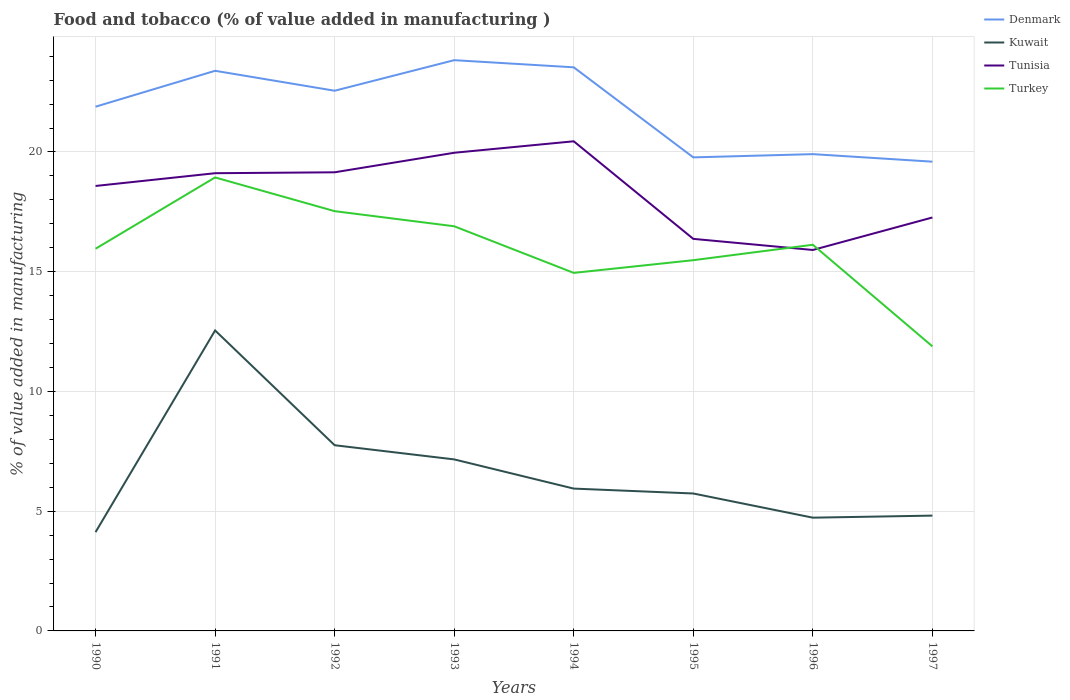How many different coloured lines are there?
Provide a succinct answer. 4. Does the line corresponding to Tunisia intersect with the line corresponding to Denmark?
Make the answer very short. No. Is the number of lines equal to the number of legend labels?
Your response must be concise. Yes. Across all years, what is the maximum value added in manufacturing food and tobacco in Tunisia?
Make the answer very short. 15.91. What is the total value added in manufacturing food and tobacco in Turkey in the graph?
Keep it short and to the point. -2.98. What is the difference between the highest and the second highest value added in manufacturing food and tobacco in Tunisia?
Provide a succinct answer. 4.54. What is the difference between the highest and the lowest value added in manufacturing food and tobacco in Tunisia?
Provide a succinct answer. 5. Is the value added in manufacturing food and tobacco in Tunisia strictly greater than the value added in manufacturing food and tobacco in Turkey over the years?
Ensure brevity in your answer.  No. How many lines are there?
Offer a very short reply. 4. Are the values on the major ticks of Y-axis written in scientific E-notation?
Offer a terse response. No. Does the graph contain any zero values?
Your response must be concise. No. Does the graph contain grids?
Your response must be concise. Yes. Where does the legend appear in the graph?
Give a very brief answer. Top right. What is the title of the graph?
Provide a succinct answer. Food and tobacco (% of value added in manufacturing ). Does "Middle East & North Africa (all income levels)" appear as one of the legend labels in the graph?
Provide a short and direct response. No. What is the label or title of the X-axis?
Ensure brevity in your answer.  Years. What is the label or title of the Y-axis?
Offer a very short reply. % of value added in manufacturing. What is the % of value added in manufacturing of Denmark in 1990?
Offer a terse response. 21.89. What is the % of value added in manufacturing in Kuwait in 1990?
Offer a terse response. 4.13. What is the % of value added in manufacturing of Tunisia in 1990?
Your answer should be very brief. 18.58. What is the % of value added in manufacturing in Turkey in 1990?
Ensure brevity in your answer.  15.96. What is the % of value added in manufacturing of Denmark in 1991?
Ensure brevity in your answer.  23.39. What is the % of value added in manufacturing of Kuwait in 1991?
Ensure brevity in your answer.  12.55. What is the % of value added in manufacturing in Tunisia in 1991?
Ensure brevity in your answer.  19.11. What is the % of value added in manufacturing of Turkey in 1991?
Your answer should be very brief. 18.94. What is the % of value added in manufacturing of Denmark in 1992?
Provide a succinct answer. 22.56. What is the % of value added in manufacturing in Kuwait in 1992?
Offer a very short reply. 7.75. What is the % of value added in manufacturing of Tunisia in 1992?
Provide a succinct answer. 19.15. What is the % of value added in manufacturing in Turkey in 1992?
Your answer should be very brief. 17.53. What is the % of value added in manufacturing in Denmark in 1993?
Offer a terse response. 23.83. What is the % of value added in manufacturing of Kuwait in 1993?
Your answer should be very brief. 7.16. What is the % of value added in manufacturing of Tunisia in 1993?
Your answer should be very brief. 19.97. What is the % of value added in manufacturing of Turkey in 1993?
Make the answer very short. 16.9. What is the % of value added in manufacturing in Denmark in 1994?
Keep it short and to the point. 23.53. What is the % of value added in manufacturing of Kuwait in 1994?
Make the answer very short. 5.94. What is the % of value added in manufacturing of Tunisia in 1994?
Provide a succinct answer. 20.45. What is the % of value added in manufacturing of Turkey in 1994?
Offer a terse response. 14.95. What is the % of value added in manufacturing in Denmark in 1995?
Your response must be concise. 19.77. What is the % of value added in manufacturing of Kuwait in 1995?
Make the answer very short. 5.74. What is the % of value added in manufacturing in Tunisia in 1995?
Provide a succinct answer. 16.37. What is the % of value added in manufacturing of Turkey in 1995?
Provide a succinct answer. 15.48. What is the % of value added in manufacturing in Denmark in 1996?
Provide a succinct answer. 19.91. What is the % of value added in manufacturing in Kuwait in 1996?
Keep it short and to the point. 4.73. What is the % of value added in manufacturing in Tunisia in 1996?
Your response must be concise. 15.91. What is the % of value added in manufacturing in Turkey in 1996?
Your response must be concise. 16.12. What is the % of value added in manufacturing of Denmark in 1997?
Offer a very short reply. 19.59. What is the % of value added in manufacturing of Kuwait in 1997?
Offer a very short reply. 4.81. What is the % of value added in manufacturing of Tunisia in 1997?
Provide a succinct answer. 17.26. What is the % of value added in manufacturing in Turkey in 1997?
Make the answer very short. 11.88. Across all years, what is the maximum % of value added in manufacturing of Denmark?
Make the answer very short. 23.83. Across all years, what is the maximum % of value added in manufacturing of Kuwait?
Keep it short and to the point. 12.55. Across all years, what is the maximum % of value added in manufacturing in Tunisia?
Ensure brevity in your answer.  20.45. Across all years, what is the maximum % of value added in manufacturing of Turkey?
Your response must be concise. 18.94. Across all years, what is the minimum % of value added in manufacturing of Denmark?
Provide a succinct answer. 19.59. Across all years, what is the minimum % of value added in manufacturing in Kuwait?
Make the answer very short. 4.13. Across all years, what is the minimum % of value added in manufacturing of Tunisia?
Ensure brevity in your answer.  15.91. Across all years, what is the minimum % of value added in manufacturing of Turkey?
Your answer should be compact. 11.88. What is the total % of value added in manufacturing in Denmark in the graph?
Provide a succinct answer. 174.48. What is the total % of value added in manufacturing in Kuwait in the graph?
Provide a succinct answer. 52.81. What is the total % of value added in manufacturing in Tunisia in the graph?
Provide a short and direct response. 146.79. What is the total % of value added in manufacturing of Turkey in the graph?
Your response must be concise. 127.76. What is the difference between the % of value added in manufacturing of Denmark in 1990 and that in 1991?
Provide a succinct answer. -1.5. What is the difference between the % of value added in manufacturing in Kuwait in 1990 and that in 1991?
Your answer should be very brief. -8.42. What is the difference between the % of value added in manufacturing of Tunisia in 1990 and that in 1991?
Make the answer very short. -0.53. What is the difference between the % of value added in manufacturing of Turkey in 1990 and that in 1991?
Provide a short and direct response. -2.98. What is the difference between the % of value added in manufacturing in Denmark in 1990 and that in 1992?
Provide a short and direct response. -0.67. What is the difference between the % of value added in manufacturing of Kuwait in 1990 and that in 1992?
Your answer should be very brief. -3.63. What is the difference between the % of value added in manufacturing in Tunisia in 1990 and that in 1992?
Give a very brief answer. -0.57. What is the difference between the % of value added in manufacturing of Turkey in 1990 and that in 1992?
Keep it short and to the point. -1.57. What is the difference between the % of value added in manufacturing in Denmark in 1990 and that in 1993?
Provide a succinct answer. -1.94. What is the difference between the % of value added in manufacturing in Kuwait in 1990 and that in 1993?
Ensure brevity in your answer.  -3.04. What is the difference between the % of value added in manufacturing in Tunisia in 1990 and that in 1993?
Offer a terse response. -1.39. What is the difference between the % of value added in manufacturing of Turkey in 1990 and that in 1993?
Give a very brief answer. -0.94. What is the difference between the % of value added in manufacturing in Denmark in 1990 and that in 1994?
Your response must be concise. -1.64. What is the difference between the % of value added in manufacturing of Kuwait in 1990 and that in 1994?
Make the answer very short. -1.82. What is the difference between the % of value added in manufacturing of Tunisia in 1990 and that in 1994?
Your answer should be compact. -1.87. What is the difference between the % of value added in manufacturing in Turkey in 1990 and that in 1994?
Keep it short and to the point. 1.01. What is the difference between the % of value added in manufacturing in Denmark in 1990 and that in 1995?
Your answer should be compact. 2.12. What is the difference between the % of value added in manufacturing of Kuwait in 1990 and that in 1995?
Provide a succinct answer. -1.61. What is the difference between the % of value added in manufacturing of Tunisia in 1990 and that in 1995?
Give a very brief answer. 2.21. What is the difference between the % of value added in manufacturing of Turkey in 1990 and that in 1995?
Your answer should be very brief. 0.48. What is the difference between the % of value added in manufacturing in Denmark in 1990 and that in 1996?
Offer a terse response. 1.98. What is the difference between the % of value added in manufacturing in Kuwait in 1990 and that in 1996?
Your answer should be very brief. -0.6. What is the difference between the % of value added in manufacturing in Tunisia in 1990 and that in 1996?
Ensure brevity in your answer.  2.67. What is the difference between the % of value added in manufacturing in Turkey in 1990 and that in 1996?
Your answer should be very brief. -0.17. What is the difference between the % of value added in manufacturing in Denmark in 1990 and that in 1997?
Offer a very short reply. 2.3. What is the difference between the % of value added in manufacturing in Kuwait in 1990 and that in 1997?
Ensure brevity in your answer.  -0.69. What is the difference between the % of value added in manufacturing in Tunisia in 1990 and that in 1997?
Offer a very short reply. 1.32. What is the difference between the % of value added in manufacturing of Turkey in 1990 and that in 1997?
Offer a terse response. 4.08. What is the difference between the % of value added in manufacturing of Denmark in 1991 and that in 1992?
Provide a succinct answer. 0.83. What is the difference between the % of value added in manufacturing in Kuwait in 1991 and that in 1992?
Provide a short and direct response. 4.79. What is the difference between the % of value added in manufacturing of Tunisia in 1991 and that in 1992?
Keep it short and to the point. -0.04. What is the difference between the % of value added in manufacturing of Turkey in 1991 and that in 1992?
Provide a short and direct response. 1.41. What is the difference between the % of value added in manufacturing of Denmark in 1991 and that in 1993?
Provide a short and direct response. -0.44. What is the difference between the % of value added in manufacturing in Kuwait in 1991 and that in 1993?
Your response must be concise. 5.38. What is the difference between the % of value added in manufacturing in Tunisia in 1991 and that in 1993?
Your answer should be very brief. -0.85. What is the difference between the % of value added in manufacturing of Turkey in 1991 and that in 1993?
Your answer should be compact. 2.04. What is the difference between the % of value added in manufacturing in Denmark in 1991 and that in 1994?
Your answer should be very brief. -0.14. What is the difference between the % of value added in manufacturing in Kuwait in 1991 and that in 1994?
Offer a terse response. 6.6. What is the difference between the % of value added in manufacturing in Tunisia in 1991 and that in 1994?
Your response must be concise. -1.33. What is the difference between the % of value added in manufacturing in Turkey in 1991 and that in 1994?
Provide a short and direct response. 3.99. What is the difference between the % of value added in manufacturing in Denmark in 1991 and that in 1995?
Provide a succinct answer. 3.62. What is the difference between the % of value added in manufacturing in Kuwait in 1991 and that in 1995?
Offer a very short reply. 6.81. What is the difference between the % of value added in manufacturing of Tunisia in 1991 and that in 1995?
Provide a short and direct response. 2.74. What is the difference between the % of value added in manufacturing in Turkey in 1991 and that in 1995?
Provide a succinct answer. 3.46. What is the difference between the % of value added in manufacturing of Denmark in 1991 and that in 1996?
Provide a short and direct response. 3.48. What is the difference between the % of value added in manufacturing of Kuwait in 1991 and that in 1996?
Your answer should be very brief. 7.82. What is the difference between the % of value added in manufacturing in Tunisia in 1991 and that in 1996?
Offer a very short reply. 3.21. What is the difference between the % of value added in manufacturing in Turkey in 1991 and that in 1996?
Ensure brevity in your answer.  2.81. What is the difference between the % of value added in manufacturing in Denmark in 1991 and that in 1997?
Your response must be concise. 3.79. What is the difference between the % of value added in manufacturing of Kuwait in 1991 and that in 1997?
Keep it short and to the point. 7.73. What is the difference between the % of value added in manufacturing in Tunisia in 1991 and that in 1997?
Offer a terse response. 1.85. What is the difference between the % of value added in manufacturing of Turkey in 1991 and that in 1997?
Offer a terse response. 7.05. What is the difference between the % of value added in manufacturing of Denmark in 1992 and that in 1993?
Your response must be concise. -1.28. What is the difference between the % of value added in manufacturing in Kuwait in 1992 and that in 1993?
Ensure brevity in your answer.  0.59. What is the difference between the % of value added in manufacturing of Tunisia in 1992 and that in 1993?
Your answer should be compact. -0.82. What is the difference between the % of value added in manufacturing in Turkey in 1992 and that in 1993?
Provide a short and direct response. 0.63. What is the difference between the % of value added in manufacturing in Denmark in 1992 and that in 1994?
Make the answer very short. -0.98. What is the difference between the % of value added in manufacturing in Kuwait in 1992 and that in 1994?
Offer a very short reply. 1.81. What is the difference between the % of value added in manufacturing of Tunisia in 1992 and that in 1994?
Offer a very short reply. -1.29. What is the difference between the % of value added in manufacturing of Turkey in 1992 and that in 1994?
Offer a very short reply. 2.58. What is the difference between the % of value added in manufacturing in Denmark in 1992 and that in 1995?
Your response must be concise. 2.78. What is the difference between the % of value added in manufacturing of Kuwait in 1992 and that in 1995?
Keep it short and to the point. 2.02. What is the difference between the % of value added in manufacturing of Tunisia in 1992 and that in 1995?
Offer a terse response. 2.78. What is the difference between the % of value added in manufacturing in Turkey in 1992 and that in 1995?
Make the answer very short. 2.05. What is the difference between the % of value added in manufacturing in Denmark in 1992 and that in 1996?
Your response must be concise. 2.65. What is the difference between the % of value added in manufacturing of Kuwait in 1992 and that in 1996?
Keep it short and to the point. 3.02. What is the difference between the % of value added in manufacturing of Tunisia in 1992 and that in 1996?
Make the answer very short. 3.24. What is the difference between the % of value added in manufacturing of Turkey in 1992 and that in 1996?
Your response must be concise. 1.4. What is the difference between the % of value added in manufacturing in Denmark in 1992 and that in 1997?
Provide a short and direct response. 2.96. What is the difference between the % of value added in manufacturing in Kuwait in 1992 and that in 1997?
Your answer should be very brief. 2.94. What is the difference between the % of value added in manufacturing of Tunisia in 1992 and that in 1997?
Offer a very short reply. 1.89. What is the difference between the % of value added in manufacturing in Turkey in 1992 and that in 1997?
Provide a short and direct response. 5.64. What is the difference between the % of value added in manufacturing of Denmark in 1993 and that in 1994?
Give a very brief answer. 0.3. What is the difference between the % of value added in manufacturing in Kuwait in 1993 and that in 1994?
Keep it short and to the point. 1.22. What is the difference between the % of value added in manufacturing in Tunisia in 1993 and that in 1994?
Make the answer very short. -0.48. What is the difference between the % of value added in manufacturing in Turkey in 1993 and that in 1994?
Your answer should be compact. 1.95. What is the difference between the % of value added in manufacturing of Denmark in 1993 and that in 1995?
Offer a very short reply. 4.06. What is the difference between the % of value added in manufacturing of Kuwait in 1993 and that in 1995?
Your answer should be compact. 1.42. What is the difference between the % of value added in manufacturing of Tunisia in 1993 and that in 1995?
Your answer should be very brief. 3.6. What is the difference between the % of value added in manufacturing in Turkey in 1993 and that in 1995?
Offer a very short reply. 1.42. What is the difference between the % of value added in manufacturing in Denmark in 1993 and that in 1996?
Your answer should be compact. 3.92. What is the difference between the % of value added in manufacturing in Kuwait in 1993 and that in 1996?
Provide a short and direct response. 2.43. What is the difference between the % of value added in manufacturing in Tunisia in 1993 and that in 1996?
Provide a succinct answer. 4.06. What is the difference between the % of value added in manufacturing of Turkey in 1993 and that in 1996?
Keep it short and to the point. 0.77. What is the difference between the % of value added in manufacturing of Denmark in 1993 and that in 1997?
Provide a short and direct response. 4.24. What is the difference between the % of value added in manufacturing in Kuwait in 1993 and that in 1997?
Your response must be concise. 2.35. What is the difference between the % of value added in manufacturing in Tunisia in 1993 and that in 1997?
Provide a succinct answer. 2.7. What is the difference between the % of value added in manufacturing in Turkey in 1993 and that in 1997?
Your response must be concise. 5.01. What is the difference between the % of value added in manufacturing of Denmark in 1994 and that in 1995?
Your response must be concise. 3.76. What is the difference between the % of value added in manufacturing of Kuwait in 1994 and that in 1995?
Your response must be concise. 0.2. What is the difference between the % of value added in manufacturing in Tunisia in 1994 and that in 1995?
Your response must be concise. 4.07. What is the difference between the % of value added in manufacturing of Turkey in 1994 and that in 1995?
Provide a short and direct response. -0.53. What is the difference between the % of value added in manufacturing of Denmark in 1994 and that in 1996?
Offer a terse response. 3.63. What is the difference between the % of value added in manufacturing in Kuwait in 1994 and that in 1996?
Provide a succinct answer. 1.21. What is the difference between the % of value added in manufacturing in Tunisia in 1994 and that in 1996?
Give a very brief answer. 4.54. What is the difference between the % of value added in manufacturing in Turkey in 1994 and that in 1996?
Ensure brevity in your answer.  -1.17. What is the difference between the % of value added in manufacturing in Denmark in 1994 and that in 1997?
Your answer should be compact. 3.94. What is the difference between the % of value added in manufacturing of Kuwait in 1994 and that in 1997?
Keep it short and to the point. 1.13. What is the difference between the % of value added in manufacturing of Tunisia in 1994 and that in 1997?
Your answer should be very brief. 3.18. What is the difference between the % of value added in manufacturing in Turkey in 1994 and that in 1997?
Ensure brevity in your answer.  3.07. What is the difference between the % of value added in manufacturing in Denmark in 1995 and that in 1996?
Your answer should be very brief. -0.14. What is the difference between the % of value added in manufacturing in Kuwait in 1995 and that in 1996?
Make the answer very short. 1.01. What is the difference between the % of value added in manufacturing of Tunisia in 1995 and that in 1996?
Your answer should be compact. 0.46. What is the difference between the % of value added in manufacturing in Turkey in 1995 and that in 1996?
Provide a short and direct response. -0.64. What is the difference between the % of value added in manufacturing of Denmark in 1995 and that in 1997?
Your answer should be very brief. 0.18. What is the difference between the % of value added in manufacturing in Kuwait in 1995 and that in 1997?
Ensure brevity in your answer.  0.92. What is the difference between the % of value added in manufacturing in Tunisia in 1995 and that in 1997?
Your response must be concise. -0.89. What is the difference between the % of value added in manufacturing of Turkey in 1995 and that in 1997?
Provide a short and direct response. 3.6. What is the difference between the % of value added in manufacturing of Denmark in 1996 and that in 1997?
Make the answer very short. 0.31. What is the difference between the % of value added in manufacturing of Kuwait in 1996 and that in 1997?
Offer a terse response. -0.09. What is the difference between the % of value added in manufacturing of Tunisia in 1996 and that in 1997?
Ensure brevity in your answer.  -1.36. What is the difference between the % of value added in manufacturing of Turkey in 1996 and that in 1997?
Give a very brief answer. 4.24. What is the difference between the % of value added in manufacturing of Denmark in 1990 and the % of value added in manufacturing of Kuwait in 1991?
Give a very brief answer. 9.34. What is the difference between the % of value added in manufacturing in Denmark in 1990 and the % of value added in manufacturing in Tunisia in 1991?
Offer a terse response. 2.78. What is the difference between the % of value added in manufacturing in Denmark in 1990 and the % of value added in manufacturing in Turkey in 1991?
Give a very brief answer. 2.95. What is the difference between the % of value added in manufacturing in Kuwait in 1990 and the % of value added in manufacturing in Tunisia in 1991?
Your response must be concise. -14.99. What is the difference between the % of value added in manufacturing in Kuwait in 1990 and the % of value added in manufacturing in Turkey in 1991?
Your response must be concise. -14.81. What is the difference between the % of value added in manufacturing in Tunisia in 1990 and the % of value added in manufacturing in Turkey in 1991?
Offer a terse response. -0.36. What is the difference between the % of value added in manufacturing in Denmark in 1990 and the % of value added in manufacturing in Kuwait in 1992?
Offer a very short reply. 14.14. What is the difference between the % of value added in manufacturing in Denmark in 1990 and the % of value added in manufacturing in Tunisia in 1992?
Your response must be concise. 2.74. What is the difference between the % of value added in manufacturing of Denmark in 1990 and the % of value added in manufacturing of Turkey in 1992?
Make the answer very short. 4.36. What is the difference between the % of value added in manufacturing of Kuwait in 1990 and the % of value added in manufacturing of Tunisia in 1992?
Give a very brief answer. -15.03. What is the difference between the % of value added in manufacturing in Kuwait in 1990 and the % of value added in manufacturing in Turkey in 1992?
Your response must be concise. -13.4. What is the difference between the % of value added in manufacturing of Tunisia in 1990 and the % of value added in manufacturing of Turkey in 1992?
Give a very brief answer. 1.05. What is the difference between the % of value added in manufacturing in Denmark in 1990 and the % of value added in manufacturing in Kuwait in 1993?
Your answer should be very brief. 14.73. What is the difference between the % of value added in manufacturing in Denmark in 1990 and the % of value added in manufacturing in Tunisia in 1993?
Provide a succinct answer. 1.92. What is the difference between the % of value added in manufacturing of Denmark in 1990 and the % of value added in manufacturing of Turkey in 1993?
Offer a terse response. 4.99. What is the difference between the % of value added in manufacturing in Kuwait in 1990 and the % of value added in manufacturing in Tunisia in 1993?
Give a very brief answer. -15.84. What is the difference between the % of value added in manufacturing of Kuwait in 1990 and the % of value added in manufacturing of Turkey in 1993?
Give a very brief answer. -12.77. What is the difference between the % of value added in manufacturing in Tunisia in 1990 and the % of value added in manufacturing in Turkey in 1993?
Your answer should be compact. 1.68. What is the difference between the % of value added in manufacturing in Denmark in 1990 and the % of value added in manufacturing in Kuwait in 1994?
Your answer should be compact. 15.95. What is the difference between the % of value added in manufacturing of Denmark in 1990 and the % of value added in manufacturing of Tunisia in 1994?
Provide a short and direct response. 1.44. What is the difference between the % of value added in manufacturing in Denmark in 1990 and the % of value added in manufacturing in Turkey in 1994?
Make the answer very short. 6.94. What is the difference between the % of value added in manufacturing of Kuwait in 1990 and the % of value added in manufacturing of Tunisia in 1994?
Your answer should be very brief. -16.32. What is the difference between the % of value added in manufacturing in Kuwait in 1990 and the % of value added in manufacturing in Turkey in 1994?
Make the answer very short. -10.82. What is the difference between the % of value added in manufacturing of Tunisia in 1990 and the % of value added in manufacturing of Turkey in 1994?
Your answer should be compact. 3.63. What is the difference between the % of value added in manufacturing of Denmark in 1990 and the % of value added in manufacturing of Kuwait in 1995?
Offer a very short reply. 16.15. What is the difference between the % of value added in manufacturing in Denmark in 1990 and the % of value added in manufacturing in Tunisia in 1995?
Provide a succinct answer. 5.52. What is the difference between the % of value added in manufacturing in Denmark in 1990 and the % of value added in manufacturing in Turkey in 1995?
Provide a succinct answer. 6.41. What is the difference between the % of value added in manufacturing in Kuwait in 1990 and the % of value added in manufacturing in Tunisia in 1995?
Make the answer very short. -12.25. What is the difference between the % of value added in manufacturing in Kuwait in 1990 and the % of value added in manufacturing in Turkey in 1995?
Offer a very short reply. -11.36. What is the difference between the % of value added in manufacturing in Tunisia in 1990 and the % of value added in manufacturing in Turkey in 1995?
Your answer should be compact. 3.1. What is the difference between the % of value added in manufacturing of Denmark in 1990 and the % of value added in manufacturing of Kuwait in 1996?
Provide a short and direct response. 17.16. What is the difference between the % of value added in manufacturing in Denmark in 1990 and the % of value added in manufacturing in Tunisia in 1996?
Your response must be concise. 5.98. What is the difference between the % of value added in manufacturing of Denmark in 1990 and the % of value added in manufacturing of Turkey in 1996?
Provide a short and direct response. 5.76. What is the difference between the % of value added in manufacturing in Kuwait in 1990 and the % of value added in manufacturing in Tunisia in 1996?
Provide a short and direct response. -11.78. What is the difference between the % of value added in manufacturing of Kuwait in 1990 and the % of value added in manufacturing of Turkey in 1996?
Your response must be concise. -12. What is the difference between the % of value added in manufacturing in Tunisia in 1990 and the % of value added in manufacturing in Turkey in 1996?
Ensure brevity in your answer.  2.45. What is the difference between the % of value added in manufacturing in Denmark in 1990 and the % of value added in manufacturing in Kuwait in 1997?
Your answer should be compact. 17.07. What is the difference between the % of value added in manufacturing in Denmark in 1990 and the % of value added in manufacturing in Tunisia in 1997?
Ensure brevity in your answer.  4.63. What is the difference between the % of value added in manufacturing in Denmark in 1990 and the % of value added in manufacturing in Turkey in 1997?
Make the answer very short. 10.01. What is the difference between the % of value added in manufacturing in Kuwait in 1990 and the % of value added in manufacturing in Tunisia in 1997?
Make the answer very short. -13.14. What is the difference between the % of value added in manufacturing in Kuwait in 1990 and the % of value added in manufacturing in Turkey in 1997?
Offer a very short reply. -7.76. What is the difference between the % of value added in manufacturing of Tunisia in 1990 and the % of value added in manufacturing of Turkey in 1997?
Your answer should be very brief. 6.7. What is the difference between the % of value added in manufacturing of Denmark in 1991 and the % of value added in manufacturing of Kuwait in 1992?
Make the answer very short. 15.64. What is the difference between the % of value added in manufacturing in Denmark in 1991 and the % of value added in manufacturing in Tunisia in 1992?
Ensure brevity in your answer.  4.24. What is the difference between the % of value added in manufacturing in Denmark in 1991 and the % of value added in manufacturing in Turkey in 1992?
Your answer should be compact. 5.86. What is the difference between the % of value added in manufacturing of Kuwait in 1991 and the % of value added in manufacturing of Tunisia in 1992?
Your response must be concise. -6.6. What is the difference between the % of value added in manufacturing of Kuwait in 1991 and the % of value added in manufacturing of Turkey in 1992?
Keep it short and to the point. -4.98. What is the difference between the % of value added in manufacturing of Tunisia in 1991 and the % of value added in manufacturing of Turkey in 1992?
Offer a terse response. 1.58. What is the difference between the % of value added in manufacturing of Denmark in 1991 and the % of value added in manufacturing of Kuwait in 1993?
Provide a succinct answer. 16.23. What is the difference between the % of value added in manufacturing in Denmark in 1991 and the % of value added in manufacturing in Tunisia in 1993?
Your answer should be compact. 3.42. What is the difference between the % of value added in manufacturing in Denmark in 1991 and the % of value added in manufacturing in Turkey in 1993?
Give a very brief answer. 6.49. What is the difference between the % of value added in manufacturing in Kuwait in 1991 and the % of value added in manufacturing in Tunisia in 1993?
Provide a short and direct response. -7.42. What is the difference between the % of value added in manufacturing in Kuwait in 1991 and the % of value added in manufacturing in Turkey in 1993?
Your response must be concise. -4.35. What is the difference between the % of value added in manufacturing of Tunisia in 1991 and the % of value added in manufacturing of Turkey in 1993?
Give a very brief answer. 2.22. What is the difference between the % of value added in manufacturing of Denmark in 1991 and the % of value added in manufacturing of Kuwait in 1994?
Your answer should be compact. 17.45. What is the difference between the % of value added in manufacturing of Denmark in 1991 and the % of value added in manufacturing of Tunisia in 1994?
Keep it short and to the point. 2.94. What is the difference between the % of value added in manufacturing of Denmark in 1991 and the % of value added in manufacturing of Turkey in 1994?
Offer a terse response. 8.44. What is the difference between the % of value added in manufacturing in Kuwait in 1991 and the % of value added in manufacturing in Tunisia in 1994?
Your response must be concise. -7.9. What is the difference between the % of value added in manufacturing of Kuwait in 1991 and the % of value added in manufacturing of Turkey in 1994?
Offer a very short reply. -2.4. What is the difference between the % of value added in manufacturing of Tunisia in 1991 and the % of value added in manufacturing of Turkey in 1994?
Offer a very short reply. 4.16. What is the difference between the % of value added in manufacturing of Denmark in 1991 and the % of value added in manufacturing of Kuwait in 1995?
Provide a succinct answer. 17.65. What is the difference between the % of value added in manufacturing of Denmark in 1991 and the % of value added in manufacturing of Tunisia in 1995?
Provide a succinct answer. 7.02. What is the difference between the % of value added in manufacturing of Denmark in 1991 and the % of value added in manufacturing of Turkey in 1995?
Your answer should be compact. 7.91. What is the difference between the % of value added in manufacturing of Kuwait in 1991 and the % of value added in manufacturing of Tunisia in 1995?
Offer a terse response. -3.82. What is the difference between the % of value added in manufacturing of Kuwait in 1991 and the % of value added in manufacturing of Turkey in 1995?
Offer a very short reply. -2.93. What is the difference between the % of value added in manufacturing of Tunisia in 1991 and the % of value added in manufacturing of Turkey in 1995?
Give a very brief answer. 3.63. What is the difference between the % of value added in manufacturing of Denmark in 1991 and the % of value added in manufacturing of Kuwait in 1996?
Offer a terse response. 18.66. What is the difference between the % of value added in manufacturing of Denmark in 1991 and the % of value added in manufacturing of Tunisia in 1996?
Give a very brief answer. 7.48. What is the difference between the % of value added in manufacturing of Denmark in 1991 and the % of value added in manufacturing of Turkey in 1996?
Make the answer very short. 7.26. What is the difference between the % of value added in manufacturing in Kuwait in 1991 and the % of value added in manufacturing in Tunisia in 1996?
Your answer should be compact. -3.36. What is the difference between the % of value added in manufacturing of Kuwait in 1991 and the % of value added in manufacturing of Turkey in 1996?
Make the answer very short. -3.58. What is the difference between the % of value added in manufacturing of Tunisia in 1991 and the % of value added in manufacturing of Turkey in 1996?
Your answer should be very brief. 2.99. What is the difference between the % of value added in manufacturing of Denmark in 1991 and the % of value added in manufacturing of Kuwait in 1997?
Your answer should be compact. 18.57. What is the difference between the % of value added in manufacturing in Denmark in 1991 and the % of value added in manufacturing in Tunisia in 1997?
Provide a succinct answer. 6.13. What is the difference between the % of value added in manufacturing in Denmark in 1991 and the % of value added in manufacturing in Turkey in 1997?
Your answer should be compact. 11.51. What is the difference between the % of value added in manufacturing in Kuwait in 1991 and the % of value added in manufacturing in Tunisia in 1997?
Provide a short and direct response. -4.72. What is the difference between the % of value added in manufacturing in Kuwait in 1991 and the % of value added in manufacturing in Turkey in 1997?
Offer a terse response. 0.66. What is the difference between the % of value added in manufacturing in Tunisia in 1991 and the % of value added in manufacturing in Turkey in 1997?
Your answer should be very brief. 7.23. What is the difference between the % of value added in manufacturing in Denmark in 1992 and the % of value added in manufacturing in Kuwait in 1993?
Your answer should be compact. 15.39. What is the difference between the % of value added in manufacturing of Denmark in 1992 and the % of value added in manufacturing of Tunisia in 1993?
Provide a succinct answer. 2.59. What is the difference between the % of value added in manufacturing of Denmark in 1992 and the % of value added in manufacturing of Turkey in 1993?
Keep it short and to the point. 5.66. What is the difference between the % of value added in manufacturing of Kuwait in 1992 and the % of value added in manufacturing of Tunisia in 1993?
Make the answer very short. -12.21. What is the difference between the % of value added in manufacturing in Kuwait in 1992 and the % of value added in manufacturing in Turkey in 1993?
Your response must be concise. -9.14. What is the difference between the % of value added in manufacturing of Tunisia in 1992 and the % of value added in manufacturing of Turkey in 1993?
Your response must be concise. 2.25. What is the difference between the % of value added in manufacturing of Denmark in 1992 and the % of value added in manufacturing of Kuwait in 1994?
Keep it short and to the point. 16.61. What is the difference between the % of value added in manufacturing of Denmark in 1992 and the % of value added in manufacturing of Tunisia in 1994?
Make the answer very short. 2.11. What is the difference between the % of value added in manufacturing in Denmark in 1992 and the % of value added in manufacturing in Turkey in 1994?
Your answer should be compact. 7.61. What is the difference between the % of value added in manufacturing of Kuwait in 1992 and the % of value added in manufacturing of Tunisia in 1994?
Make the answer very short. -12.69. What is the difference between the % of value added in manufacturing in Kuwait in 1992 and the % of value added in manufacturing in Turkey in 1994?
Offer a terse response. -7.2. What is the difference between the % of value added in manufacturing of Tunisia in 1992 and the % of value added in manufacturing of Turkey in 1994?
Your answer should be compact. 4.2. What is the difference between the % of value added in manufacturing of Denmark in 1992 and the % of value added in manufacturing of Kuwait in 1995?
Provide a succinct answer. 16.82. What is the difference between the % of value added in manufacturing in Denmark in 1992 and the % of value added in manufacturing in Tunisia in 1995?
Give a very brief answer. 6.19. What is the difference between the % of value added in manufacturing in Denmark in 1992 and the % of value added in manufacturing in Turkey in 1995?
Your response must be concise. 7.08. What is the difference between the % of value added in manufacturing of Kuwait in 1992 and the % of value added in manufacturing of Tunisia in 1995?
Offer a terse response. -8.62. What is the difference between the % of value added in manufacturing of Kuwait in 1992 and the % of value added in manufacturing of Turkey in 1995?
Your answer should be compact. -7.73. What is the difference between the % of value added in manufacturing in Tunisia in 1992 and the % of value added in manufacturing in Turkey in 1995?
Offer a very short reply. 3.67. What is the difference between the % of value added in manufacturing of Denmark in 1992 and the % of value added in manufacturing of Kuwait in 1996?
Give a very brief answer. 17.83. What is the difference between the % of value added in manufacturing of Denmark in 1992 and the % of value added in manufacturing of Tunisia in 1996?
Your answer should be very brief. 6.65. What is the difference between the % of value added in manufacturing of Denmark in 1992 and the % of value added in manufacturing of Turkey in 1996?
Provide a short and direct response. 6.43. What is the difference between the % of value added in manufacturing in Kuwait in 1992 and the % of value added in manufacturing in Tunisia in 1996?
Offer a very short reply. -8.15. What is the difference between the % of value added in manufacturing of Kuwait in 1992 and the % of value added in manufacturing of Turkey in 1996?
Keep it short and to the point. -8.37. What is the difference between the % of value added in manufacturing in Tunisia in 1992 and the % of value added in manufacturing in Turkey in 1996?
Keep it short and to the point. 3.03. What is the difference between the % of value added in manufacturing of Denmark in 1992 and the % of value added in manufacturing of Kuwait in 1997?
Offer a terse response. 17.74. What is the difference between the % of value added in manufacturing in Denmark in 1992 and the % of value added in manufacturing in Tunisia in 1997?
Make the answer very short. 5.29. What is the difference between the % of value added in manufacturing in Denmark in 1992 and the % of value added in manufacturing in Turkey in 1997?
Make the answer very short. 10.67. What is the difference between the % of value added in manufacturing in Kuwait in 1992 and the % of value added in manufacturing in Tunisia in 1997?
Make the answer very short. -9.51. What is the difference between the % of value added in manufacturing of Kuwait in 1992 and the % of value added in manufacturing of Turkey in 1997?
Ensure brevity in your answer.  -4.13. What is the difference between the % of value added in manufacturing of Tunisia in 1992 and the % of value added in manufacturing of Turkey in 1997?
Make the answer very short. 7.27. What is the difference between the % of value added in manufacturing in Denmark in 1993 and the % of value added in manufacturing in Kuwait in 1994?
Your answer should be very brief. 17.89. What is the difference between the % of value added in manufacturing of Denmark in 1993 and the % of value added in manufacturing of Tunisia in 1994?
Provide a succinct answer. 3.39. What is the difference between the % of value added in manufacturing of Denmark in 1993 and the % of value added in manufacturing of Turkey in 1994?
Your answer should be very brief. 8.88. What is the difference between the % of value added in manufacturing of Kuwait in 1993 and the % of value added in manufacturing of Tunisia in 1994?
Offer a terse response. -13.28. What is the difference between the % of value added in manufacturing in Kuwait in 1993 and the % of value added in manufacturing in Turkey in 1994?
Your answer should be very brief. -7.79. What is the difference between the % of value added in manufacturing of Tunisia in 1993 and the % of value added in manufacturing of Turkey in 1994?
Your response must be concise. 5.02. What is the difference between the % of value added in manufacturing of Denmark in 1993 and the % of value added in manufacturing of Kuwait in 1995?
Offer a very short reply. 18.09. What is the difference between the % of value added in manufacturing of Denmark in 1993 and the % of value added in manufacturing of Tunisia in 1995?
Provide a short and direct response. 7.46. What is the difference between the % of value added in manufacturing of Denmark in 1993 and the % of value added in manufacturing of Turkey in 1995?
Make the answer very short. 8.35. What is the difference between the % of value added in manufacturing of Kuwait in 1993 and the % of value added in manufacturing of Tunisia in 1995?
Your answer should be very brief. -9.21. What is the difference between the % of value added in manufacturing of Kuwait in 1993 and the % of value added in manufacturing of Turkey in 1995?
Offer a very short reply. -8.32. What is the difference between the % of value added in manufacturing in Tunisia in 1993 and the % of value added in manufacturing in Turkey in 1995?
Make the answer very short. 4.49. What is the difference between the % of value added in manufacturing in Denmark in 1993 and the % of value added in manufacturing in Kuwait in 1996?
Provide a succinct answer. 19.1. What is the difference between the % of value added in manufacturing of Denmark in 1993 and the % of value added in manufacturing of Tunisia in 1996?
Your response must be concise. 7.93. What is the difference between the % of value added in manufacturing in Denmark in 1993 and the % of value added in manufacturing in Turkey in 1996?
Give a very brief answer. 7.71. What is the difference between the % of value added in manufacturing in Kuwait in 1993 and the % of value added in manufacturing in Tunisia in 1996?
Offer a terse response. -8.74. What is the difference between the % of value added in manufacturing of Kuwait in 1993 and the % of value added in manufacturing of Turkey in 1996?
Keep it short and to the point. -8.96. What is the difference between the % of value added in manufacturing of Tunisia in 1993 and the % of value added in manufacturing of Turkey in 1996?
Provide a succinct answer. 3.84. What is the difference between the % of value added in manufacturing of Denmark in 1993 and the % of value added in manufacturing of Kuwait in 1997?
Ensure brevity in your answer.  19.02. What is the difference between the % of value added in manufacturing in Denmark in 1993 and the % of value added in manufacturing in Tunisia in 1997?
Provide a short and direct response. 6.57. What is the difference between the % of value added in manufacturing in Denmark in 1993 and the % of value added in manufacturing in Turkey in 1997?
Give a very brief answer. 11.95. What is the difference between the % of value added in manufacturing in Kuwait in 1993 and the % of value added in manufacturing in Tunisia in 1997?
Ensure brevity in your answer.  -10.1. What is the difference between the % of value added in manufacturing in Kuwait in 1993 and the % of value added in manufacturing in Turkey in 1997?
Give a very brief answer. -4.72. What is the difference between the % of value added in manufacturing in Tunisia in 1993 and the % of value added in manufacturing in Turkey in 1997?
Give a very brief answer. 8.08. What is the difference between the % of value added in manufacturing in Denmark in 1994 and the % of value added in manufacturing in Kuwait in 1995?
Ensure brevity in your answer.  17.8. What is the difference between the % of value added in manufacturing in Denmark in 1994 and the % of value added in manufacturing in Tunisia in 1995?
Offer a terse response. 7.16. What is the difference between the % of value added in manufacturing of Denmark in 1994 and the % of value added in manufacturing of Turkey in 1995?
Ensure brevity in your answer.  8.05. What is the difference between the % of value added in manufacturing in Kuwait in 1994 and the % of value added in manufacturing in Tunisia in 1995?
Your answer should be very brief. -10.43. What is the difference between the % of value added in manufacturing of Kuwait in 1994 and the % of value added in manufacturing of Turkey in 1995?
Ensure brevity in your answer.  -9.54. What is the difference between the % of value added in manufacturing in Tunisia in 1994 and the % of value added in manufacturing in Turkey in 1995?
Offer a terse response. 4.96. What is the difference between the % of value added in manufacturing in Denmark in 1994 and the % of value added in manufacturing in Kuwait in 1996?
Offer a very short reply. 18.8. What is the difference between the % of value added in manufacturing in Denmark in 1994 and the % of value added in manufacturing in Tunisia in 1996?
Offer a terse response. 7.63. What is the difference between the % of value added in manufacturing of Denmark in 1994 and the % of value added in manufacturing of Turkey in 1996?
Ensure brevity in your answer.  7.41. What is the difference between the % of value added in manufacturing in Kuwait in 1994 and the % of value added in manufacturing in Tunisia in 1996?
Your answer should be compact. -9.96. What is the difference between the % of value added in manufacturing in Kuwait in 1994 and the % of value added in manufacturing in Turkey in 1996?
Keep it short and to the point. -10.18. What is the difference between the % of value added in manufacturing in Tunisia in 1994 and the % of value added in manufacturing in Turkey in 1996?
Your answer should be very brief. 4.32. What is the difference between the % of value added in manufacturing of Denmark in 1994 and the % of value added in manufacturing of Kuwait in 1997?
Your answer should be compact. 18.72. What is the difference between the % of value added in manufacturing in Denmark in 1994 and the % of value added in manufacturing in Tunisia in 1997?
Your answer should be compact. 6.27. What is the difference between the % of value added in manufacturing of Denmark in 1994 and the % of value added in manufacturing of Turkey in 1997?
Give a very brief answer. 11.65. What is the difference between the % of value added in manufacturing in Kuwait in 1994 and the % of value added in manufacturing in Tunisia in 1997?
Offer a terse response. -11.32. What is the difference between the % of value added in manufacturing in Kuwait in 1994 and the % of value added in manufacturing in Turkey in 1997?
Provide a short and direct response. -5.94. What is the difference between the % of value added in manufacturing in Tunisia in 1994 and the % of value added in manufacturing in Turkey in 1997?
Ensure brevity in your answer.  8.56. What is the difference between the % of value added in manufacturing in Denmark in 1995 and the % of value added in manufacturing in Kuwait in 1996?
Offer a very short reply. 15.04. What is the difference between the % of value added in manufacturing in Denmark in 1995 and the % of value added in manufacturing in Tunisia in 1996?
Make the answer very short. 3.87. What is the difference between the % of value added in manufacturing of Denmark in 1995 and the % of value added in manufacturing of Turkey in 1996?
Your answer should be compact. 3.65. What is the difference between the % of value added in manufacturing in Kuwait in 1995 and the % of value added in manufacturing in Tunisia in 1996?
Your response must be concise. -10.17. What is the difference between the % of value added in manufacturing in Kuwait in 1995 and the % of value added in manufacturing in Turkey in 1996?
Make the answer very short. -10.39. What is the difference between the % of value added in manufacturing in Tunisia in 1995 and the % of value added in manufacturing in Turkey in 1996?
Offer a terse response. 0.25. What is the difference between the % of value added in manufacturing of Denmark in 1995 and the % of value added in manufacturing of Kuwait in 1997?
Offer a terse response. 14.96. What is the difference between the % of value added in manufacturing of Denmark in 1995 and the % of value added in manufacturing of Tunisia in 1997?
Ensure brevity in your answer.  2.51. What is the difference between the % of value added in manufacturing of Denmark in 1995 and the % of value added in manufacturing of Turkey in 1997?
Provide a succinct answer. 7.89. What is the difference between the % of value added in manufacturing of Kuwait in 1995 and the % of value added in manufacturing of Tunisia in 1997?
Ensure brevity in your answer.  -11.52. What is the difference between the % of value added in manufacturing in Kuwait in 1995 and the % of value added in manufacturing in Turkey in 1997?
Make the answer very short. -6.14. What is the difference between the % of value added in manufacturing in Tunisia in 1995 and the % of value added in manufacturing in Turkey in 1997?
Your answer should be compact. 4.49. What is the difference between the % of value added in manufacturing in Denmark in 1996 and the % of value added in manufacturing in Kuwait in 1997?
Keep it short and to the point. 15.09. What is the difference between the % of value added in manufacturing of Denmark in 1996 and the % of value added in manufacturing of Tunisia in 1997?
Provide a succinct answer. 2.65. What is the difference between the % of value added in manufacturing of Denmark in 1996 and the % of value added in manufacturing of Turkey in 1997?
Your response must be concise. 8.03. What is the difference between the % of value added in manufacturing of Kuwait in 1996 and the % of value added in manufacturing of Tunisia in 1997?
Make the answer very short. -12.53. What is the difference between the % of value added in manufacturing of Kuwait in 1996 and the % of value added in manufacturing of Turkey in 1997?
Provide a short and direct response. -7.15. What is the difference between the % of value added in manufacturing in Tunisia in 1996 and the % of value added in manufacturing in Turkey in 1997?
Keep it short and to the point. 4.02. What is the average % of value added in manufacturing in Denmark per year?
Make the answer very short. 21.81. What is the average % of value added in manufacturing of Kuwait per year?
Your answer should be very brief. 6.6. What is the average % of value added in manufacturing in Tunisia per year?
Your answer should be very brief. 18.35. What is the average % of value added in manufacturing of Turkey per year?
Provide a short and direct response. 15.97. In the year 1990, what is the difference between the % of value added in manufacturing in Denmark and % of value added in manufacturing in Kuwait?
Ensure brevity in your answer.  17.76. In the year 1990, what is the difference between the % of value added in manufacturing of Denmark and % of value added in manufacturing of Tunisia?
Ensure brevity in your answer.  3.31. In the year 1990, what is the difference between the % of value added in manufacturing of Denmark and % of value added in manufacturing of Turkey?
Offer a terse response. 5.93. In the year 1990, what is the difference between the % of value added in manufacturing of Kuwait and % of value added in manufacturing of Tunisia?
Provide a succinct answer. -14.45. In the year 1990, what is the difference between the % of value added in manufacturing in Kuwait and % of value added in manufacturing in Turkey?
Offer a very short reply. -11.83. In the year 1990, what is the difference between the % of value added in manufacturing in Tunisia and % of value added in manufacturing in Turkey?
Your response must be concise. 2.62. In the year 1991, what is the difference between the % of value added in manufacturing of Denmark and % of value added in manufacturing of Kuwait?
Provide a short and direct response. 10.84. In the year 1991, what is the difference between the % of value added in manufacturing in Denmark and % of value added in manufacturing in Tunisia?
Give a very brief answer. 4.28. In the year 1991, what is the difference between the % of value added in manufacturing of Denmark and % of value added in manufacturing of Turkey?
Your response must be concise. 4.45. In the year 1991, what is the difference between the % of value added in manufacturing in Kuwait and % of value added in manufacturing in Tunisia?
Make the answer very short. -6.57. In the year 1991, what is the difference between the % of value added in manufacturing of Kuwait and % of value added in manufacturing of Turkey?
Your answer should be very brief. -6.39. In the year 1991, what is the difference between the % of value added in manufacturing in Tunisia and % of value added in manufacturing in Turkey?
Keep it short and to the point. 0.18. In the year 1992, what is the difference between the % of value added in manufacturing of Denmark and % of value added in manufacturing of Kuwait?
Ensure brevity in your answer.  14.8. In the year 1992, what is the difference between the % of value added in manufacturing in Denmark and % of value added in manufacturing in Tunisia?
Provide a short and direct response. 3.41. In the year 1992, what is the difference between the % of value added in manufacturing of Denmark and % of value added in manufacturing of Turkey?
Your answer should be compact. 5.03. In the year 1992, what is the difference between the % of value added in manufacturing in Kuwait and % of value added in manufacturing in Tunisia?
Offer a very short reply. -11.4. In the year 1992, what is the difference between the % of value added in manufacturing in Kuwait and % of value added in manufacturing in Turkey?
Your response must be concise. -9.77. In the year 1992, what is the difference between the % of value added in manufacturing in Tunisia and % of value added in manufacturing in Turkey?
Keep it short and to the point. 1.62. In the year 1993, what is the difference between the % of value added in manufacturing of Denmark and % of value added in manufacturing of Kuwait?
Your answer should be very brief. 16.67. In the year 1993, what is the difference between the % of value added in manufacturing in Denmark and % of value added in manufacturing in Tunisia?
Your answer should be compact. 3.87. In the year 1993, what is the difference between the % of value added in manufacturing in Denmark and % of value added in manufacturing in Turkey?
Provide a succinct answer. 6.94. In the year 1993, what is the difference between the % of value added in manufacturing of Kuwait and % of value added in manufacturing of Tunisia?
Give a very brief answer. -12.8. In the year 1993, what is the difference between the % of value added in manufacturing in Kuwait and % of value added in manufacturing in Turkey?
Your answer should be compact. -9.73. In the year 1993, what is the difference between the % of value added in manufacturing of Tunisia and % of value added in manufacturing of Turkey?
Your answer should be very brief. 3.07. In the year 1994, what is the difference between the % of value added in manufacturing of Denmark and % of value added in manufacturing of Kuwait?
Your answer should be compact. 17.59. In the year 1994, what is the difference between the % of value added in manufacturing of Denmark and % of value added in manufacturing of Tunisia?
Provide a short and direct response. 3.09. In the year 1994, what is the difference between the % of value added in manufacturing of Denmark and % of value added in manufacturing of Turkey?
Ensure brevity in your answer.  8.58. In the year 1994, what is the difference between the % of value added in manufacturing of Kuwait and % of value added in manufacturing of Tunisia?
Your response must be concise. -14.5. In the year 1994, what is the difference between the % of value added in manufacturing in Kuwait and % of value added in manufacturing in Turkey?
Your response must be concise. -9.01. In the year 1994, what is the difference between the % of value added in manufacturing of Tunisia and % of value added in manufacturing of Turkey?
Offer a terse response. 5.49. In the year 1995, what is the difference between the % of value added in manufacturing in Denmark and % of value added in manufacturing in Kuwait?
Ensure brevity in your answer.  14.03. In the year 1995, what is the difference between the % of value added in manufacturing of Denmark and % of value added in manufacturing of Tunisia?
Provide a succinct answer. 3.4. In the year 1995, what is the difference between the % of value added in manufacturing of Denmark and % of value added in manufacturing of Turkey?
Your answer should be compact. 4.29. In the year 1995, what is the difference between the % of value added in manufacturing in Kuwait and % of value added in manufacturing in Tunisia?
Give a very brief answer. -10.63. In the year 1995, what is the difference between the % of value added in manufacturing in Kuwait and % of value added in manufacturing in Turkey?
Provide a short and direct response. -9.74. In the year 1995, what is the difference between the % of value added in manufacturing in Tunisia and % of value added in manufacturing in Turkey?
Make the answer very short. 0.89. In the year 1996, what is the difference between the % of value added in manufacturing of Denmark and % of value added in manufacturing of Kuwait?
Your response must be concise. 15.18. In the year 1996, what is the difference between the % of value added in manufacturing in Denmark and % of value added in manufacturing in Tunisia?
Provide a succinct answer. 4. In the year 1996, what is the difference between the % of value added in manufacturing in Denmark and % of value added in manufacturing in Turkey?
Provide a short and direct response. 3.78. In the year 1996, what is the difference between the % of value added in manufacturing of Kuwait and % of value added in manufacturing of Tunisia?
Offer a very short reply. -11.18. In the year 1996, what is the difference between the % of value added in manufacturing of Kuwait and % of value added in manufacturing of Turkey?
Your response must be concise. -11.4. In the year 1996, what is the difference between the % of value added in manufacturing of Tunisia and % of value added in manufacturing of Turkey?
Make the answer very short. -0.22. In the year 1997, what is the difference between the % of value added in manufacturing of Denmark and % of value added in manufacturing of Kuwait?
Your answer should be compact. 14.78. In the year 1997, what is the difference between the % of value added in manufacturing in Denmark and % of value added in manufacturing in Tunisia?
Your answer should be very brief. 2.33. In the year 1997, what is the difference between the % of value added in manufacturing of Denmark and % of value added in manufacturing of Turkey?
Make the answer very short. 7.71. In the year 1997, what is the difference between the % of value added in manufacturing of Kuwait and % of value added in manufacturing of Tunisia?
Your answer should be very brief. -12.45. In the year 1997, what is the difference between the % of value added in manufacturing of Kuwait and % of value added in manufacturing of Turkey?
Your response must be concise. -7.07. In the year 1997, what is the difference between the % of value added in manufacturing of Tunisia and % of value added in manufacturing of Turkey?
Ensure brevity in your answer.  5.38. What is the ratio of the % of value added in manufacturing of Denmark in 1990 to that in 1991?
Keep it short and to the point. 0.94. What is the ratio of the % of value added in manufacturing of Kuwait in 1990 to that in 1991?
Your response must be concise. 0.33. What is the ratio of the % of value added in manufacturing in Tunisia in 1990 to that in 1991?
Your response must be concise. 0.97. What is the ratio of the % of value added in manufacturing of Turkey in 1990 to that in 1991?
Offer a very short reply. 0.84. What is the ratio of the % of value added in manufacturing of Denmark in 1990 to that in 1992?
Your response must be concise. 0.97. What is the ratio of the % of value added in manufacturing in Kuwait in 1990 to that in 1992?
Your response must be concise. 0.53. What is the ratio of the % of value added in manufacturing of Tunisia in 1990 to that in 1992?
Ensure brevity in your answer.  0.97. What is the ratio of the % of value added in manufacturing of Turkey in 1990 to that in 1992?
Your answer should be compact. 0.91. What is the ratio of the % of value added in manufacturing in Denmark in 1990 to that in 1993?
Offer a terse response. 0.92. What is the ratio of the % of value added in manufacturing of Kuwait in 1990 to that in 1993?
Your response must be concise. 0.58. What is the ratio of the % of value added in manufacturing of Tunisia in 1990 to that in 1993?
Your answer should be compact. 0.93. What is the ratio of the % of value added in manufacturing of Turkey in 1990 to that in 1993?
Provide a short and direct response. 0.94. What is the ratio of the % of value added in manufacturing in Denmark in 1990 to that in 1994?
Give a very brief answer. 0.93. What is the ratio of the % of value added in manufacturing in Kuwait in 1990 to that in 1994?
Your answer should be very brief. 0.69. What is the ratio of the % of value added in manufacturing of Tunisia in 1990 to that in 1994?
Provide a succinct answer. 0.91. What is the ratio of the % of value added in manufacturing in Turkey in 1990 to that in 1994?
Ensure brevity in your answer.  1.07. What is the ratio of the % of value added in manufacturing of Denmark in 1990 to that in 1995?
Keep it short and to the point. 1.11. What is the ratio of the % of value added in manufacturing of Kuwait in 1990 to that in 1995?
Your response must be concise. 0.72. What is the ratio of the % of value added in manufacturing in Tunisia in 1990 to that in 1995?
Keep it short and to the point. 1.13. What is the ratio of the % of value added in manufacturing in Turkey in 1990 to that in 1995?
Make the answer very short. 1.03. What is the ratio of the % of value added in manufacturing of Denmark in 1990 to that in 1996?
Your answer should be very brief. 1.1. What is the ratio of the % of value added in manufacturing of Kuwait in 1990 to that in 1996?
Offer a terse response. 0.87. What is the ratio of the % of value added in manufacturing in Tunisia in 1990 to that in 1996?
Make the answer very short. 1.17. What is the ratio of the % of value added in manufacturing in Denmark in 1990 to that in 1997?
Offer a very short reply. 1.12. What is the ratio of the % of value added in manufacturing in Kuwait in 1990 to that in 1997?
Give a very brief answer. 0.86. What is the ratio of the % of value added in manufacturing in Tunisia in 1990 to that in 1997?
Your response must be concise. 1.08. What is the ratio of the % of value added in manufacturing of Turkey in 1990 to that in 1997?
Offer a terse response. 1.34. What is the ratio of the % of value added in manufacturing of Denmark in 1991 to that in 1992?
Give a very brief answer. 1.04. What is the ratio of the % of value added in manufacturing in Kuwait in 1991 to that in 1992?
Your answer should be very brief. 1.62. What is the ratio of the % of value added in manufacturing in Tunisia in 1991 to that in 1992?
Make the answer very short. 1. What is the ratio of the % of value added in manufacturing of Turkey in 1991 to that in 1992?
Make the answer very short. 1.08. What is the ratio of the % of value added in manufacturing in Denmark in 1991 to that in 1993?
Keep it short and to the point. 0.98. What is the ratio of the % of value added in manufacturing in Kuwait in 1991 to that in 1993?
Your response must be concise. 1.75. What is the ratio of the % of value added in manufacturing in Tunisia in 1991 to that in 1993?
Your response must be concise. 0.96. What is the ratio of the % of value added in manufacturing of Turkey in 1991 to that in 1993?
Your answer should be compact. 1.12. What is the ratio of the % of value added in manufacturing of Denmark in 1991 to that in 1994?
Provide a succinct answer. 0.99. What is the ratio of the % of value added in manufacturing of Kuwait in 1991 to that in 1994?
Keep it short and to the point. 2.11. What is the ratio of the % of value added in manufacturing in Tunisia in 1991 to that in 1994?
Your answer should be compact. 0.93. What is the ratio of the % of value added in manufacturing in Turkey in 1991 to that in 1994?
Your response must be concise. 1.27. What is the ratio of the % of value added in manufacturing of Denmark in 1991 to that in 1995?
Offer a very short reply. 1.18. What is the ratio of the % of value added in manufacturing of Kuwait in 1991 to that in 1995?
Give a very brief answer. 2.19. What is the ratio of the % of value added in manufacturing of Tunisia in 1991 to that in 1995?
Keep it short and to the point. 1.17. What is the ratio of the % of value added in manufacturing of Turkey in 1991 to that in 1995?
Provide a short and direct response. 1.22. What is the ratio of the % of value added in manufacturing of Denmark in 1991 to that in 1996?
Your answer should be very brief. 1.17. What is the ratio of the % of value added in manufacturing in Kuwait in 1991 to that in 1996?
Give a very brief answer. 2.65. What is the ratio of the % of value added in manufacturing of Tunisia in 1991 to that in 1996?
Offer a terse response. 1.2. What is the ratio of the % of value added in manufacturing in Turkey in 1991 to that in 1996?
Offer a very short reply. 1.17. What is the ratio of the % of value added in manufacturing in Denmark in 1991 to that in 1997?
Make the answer very short. 1.19. What is the ratio of the % of value added in manufacturing of Kuwait in 1991 to that in 1997?
Your answer should be compact. 2.61. What is the ratio of the % of value added in manufacturing of Tunisia in 1991 to that in 1997?
Keep it short and to the point. 1.11. What is the ratio of the % of value added in manufacturing of Turkey in 1991 to that in 1997?
Offer a terse response. 1.59. What is the ratio of the % of value added in manufacturing of Denmark in 1992 to that in 1993?
Provide a short and direct response. 0.95. What is the ratio of the % of value added in manufacturing in Kuwait in 1992 to that in 1993?
Ensure brevity in your answer.  1.08. What is the ratio of the % of value added in manufacturing of Tunisia in 1992 to that in 1993?
Your response must be concise. 0.96. What is the ratio of the % of value added in manufacturing in Turkey in 1992 to that in 1993?
Provide a succinct answer. 1.04. What is the ratio of the % of value added in manufacturing of Denmark in 1992 to that in 1994?
Make the answer very short. 0.96. What is the ratio of the % of value added in manufacturing of Kuwait in 1992 to that in 1994?
Your answer should be very brief. 1.3. What is the ratio of the % of value added in manufacturing in Tunisia in 1992 to that in 1994?
Give a very brief answer. 0.94. What is the ratio of the % of value added in manufacturing of Turkey in 1992 to that in 1994?
Ensure brevity in your answer.  1.17. What is the ratio of the % of value added in manufacturing of Denmark in 1992 to that in 1995?
Your answer should be compact. 1.14. What is the ratio of the % of value added in manufacturing of Kuwait in 1992 to that in 1995?
Keep it short and to the point. 1.35. What is the ratio of the % of value added in manufacturing in Tunisia in 1992 to that in 1995?
Ensure brevity in your answer.  1.17. What is the ratio of the % of value added in manufacturing of Turkey in 1992 to that in 1995?
Keep it short and to the point. 1.13. What is the ratio of the % of value added in manufacturing in Denmark in 1992 to that in 1996?
Keep it short and to the point. 1.13. What is the ratio of the % of value added in manufacturing in Kuwait in 1992 to that in 1996?
Offer a terse response. 1.64. What is the ratio of the % of value added in manufacturing in Tunisia in 1992 to that in 1996?
Ensure brevity in your answer.  1.2. What is the ratio of the % of value added in manufacturing in Turkey in 1992 to that in 1996?
Your answer should be very brief. 1.09. What is the ratio of the % of value added in manufacturing in Denmark in 1992 to that in 1997?
Keep it short and to the point. 1.15. What is the ratio of the % of value added in manufacturing of Kuwait in 1992 to that in 1997?
Your response must be concise. 1.61. What is the ratio of the % of value added in manufacturing in Tunisia in 1992 to that in 1997?
Provide a succinct answer. 1.11. What is the ratio of the % of value added in manufacturing of Turkey in 1992 to that in 1997?
Offer a terse response. 1.48. What is the ratio of the % of value added in manufacturing in Denmark in 1993 to that in 1994?
Ensure brevity in your answer.  1.01. What is the ratio of the % of value added in manufacturing in Kuwait in 1993 to that in 1994?
Keep it short and to the point. 1.21. What is the ratio of the % of value added in manufacturing of Tunisia in 1993 to that in 1994?
Provide a short and direct response. 0.98. What is the ratio of the % of value added in manufacturing of Turkey in 1993 to that in 1994?
Offer a terse response. 1.13. What is the ratio of the % of value added in manufacturing in Denmark in 1993 to that in 1995?
Your answer should be very brief. 1.21. What is the ratio of the % of value added in manufacturing in Kuwait in 1993 to that in 1995?
Provide a short and direct response. 1.25. What is the ratio of the % of value added in manufacturing of Tunisia in 1993 to that in 1995?
Keep it short and to the point. 1.22. What is the ratio of the % of value added in manufacturing in Turkey in 1993 to that in 1995?
Provide a succinct answer. 1.09. What is the ratio of the % of value added in manufacturing in Denmark in 1993 to that in 1996?
Provide a succinct answer. 1.2. What is the ratio of the % of value added in manufacturing in Kuwait in 1993 to that in 1996?
Your answer should be compact. 1.51. What is the ratio of the % of value added in manufacturing of Tunisia in 1993 to that in 1996?
Provide a short and direct response. 1.26. What is the ratio of the % of value added in manufacturing of Turkey in 1993 to that in 1996?
Ensure brevity in your answer.  1.05. What is the ratio of the % of value added in manufacturing of Denmark in 1993 to that in 1997?
Provide a short and direct response. 1.22. What is the ratio of the % of value added in manufacturing of Kuwait in 1993 to that in 1997?
Your response must be concise. 1.49. What is the ratio of the % of value added in manufacturing of Tunisia in 1993 to that in 1997?
Keep it short and to the point. 1.16. What is the ratio of the % of value added in manufacturing of Turkey in 1993 to that in 1997?
Give a very brief answer. 1.42. What is the ratio of the % of value added in manufacturing of Denmark in 1994 to that in 1995?
Give a very brief answer. 1.19. What is the ratio of the % of value added in manufacturing in Kuwait in 1994 to that in 1995?
Your answer should be compact. 1.04. What is the ratio of the % of value added in manufacturing in Tunisia in 1994 to that in 1995?
Your answer should be very brief. 1.25. What is the ratio of the % of value added in manufacturing in Turkey in 1994 to that in 1995?
Your answer should be very brief. 0.97. What is the ratio of the % of value added in manufacturing in Denmark in 1994 to that in 1996?
Provide a succinct answer. 1.18. What is the ratio of the % of value added in manufacturing of Kuwait in 1994 to that in 1996?
Keep it short and to the point. 1.26. What is the ratio of the % of value added in manufacturing of Tunisia in 1994 to that in 1996?
Ensure brevity in your answer.  1.29. What is the ratio of the % of value added in manufacturing in Turkey in 1994 to that in 1996?
Ensure brevity in your answer.  0.93. What is the ratio of the % of value added in manufacturing of Denmark in 1994 to that in 1997?
Make the answer very short. 1.2. What is the ratio of the % of value added in manufacturing in Kuwait in 1994 to that in 1997?
Your response must be concise. 1.23. What is the ratio of the % of value added in manufacturing of Tunisia in 1994 to that in 1997?
Your answer should be compact. 1.18. What is the ratio of the % of value added in manufacturing in Turkey in 1994 to that in 1997?
Offer a terse response. 1.26. What is the ratio of the % of value added in manufacturing in Denmark in 1995 to that in 1996?
Give a very brief answer. 0.99. What is the ratio of the % of value added in manufacturing in Kuwait in 1995 to that in 1996?
Offer a very short reply. 1.21. What is the ratio of the % of value added in manufacturing of Tunisia in 1995 to that in 1996?
Provide a succinct answer. 1.03. What is the ratio of the % of value added in manufacturing in Turkey in 1995 to that in 1996?
Offer a very short reply. 0.96. What is the ratio of the % of value added in manufacturing in Denmark in 1995 to that in 1997?
Your answer should be very brief. 1.01. What is the ratio of the % of value added in manufacturing in Kuwait in 1995 to that in 1997?
Provide a short and direct response. 1.19. What is the ratio of the % of value added in manufacturing in Tunisia in 1995 to that in 1997?
Your response must be concise. 0.95. What is the ratio of the % of value added in manufacturing of Turkey in 1995 to that in 1997?
Keep it short and to the point. 1.3. What is the ratio of the % of value added in manufacturing in Denmark in 1996 to that in 1997?
Provide a succinct answer. 1.02. What is the ratio of the % of value added in manufacturing of Kuwait in 1996 to that in 1997?
Keep it short and to the point. 0.98. What is the ratio of the % of value added in manufacturing of Tunisia in 1996 to that in 1997?
Offer a terse response. 0.92. What is the ratio of the % of value added in manufacturing of Turkey in 1996 to that in 1997?
Give a very brief answer. 1.36. What is the difference between the highest and the second highest % of value added in manufacturing of Denmark?
Provide a short and direct response. 0.3. What is the difference between the highest and the second highest % of value added in manufacturing of Kuwait?
Offer a very short reply. 4.79. What is the difference between the highest and the second highest % of value added in manufacturing of Tunisia?
Your answer should be very brief. 0.48. What is the difference between the highest and the second highest % of value added in manufacturing of Turkey?
Offer a terse response. 1.41. What is the difference between the highest and the lowest % of value added in manufacturing in Denmark?
Your answer should be compact. 4.24. What is the difference between the highest and the lowest % of value added in manufacturing in Kuwait?
Your response must be concise. 8.42. What is the difference between the highest and the lowest % of value added in manufacturing of Tunisia?
Provide a short and direct response. 4.54. What is the difference between the highest and the lowest % of value added in manufacturing in Turkey?
Offer a terse response. 7.05. 